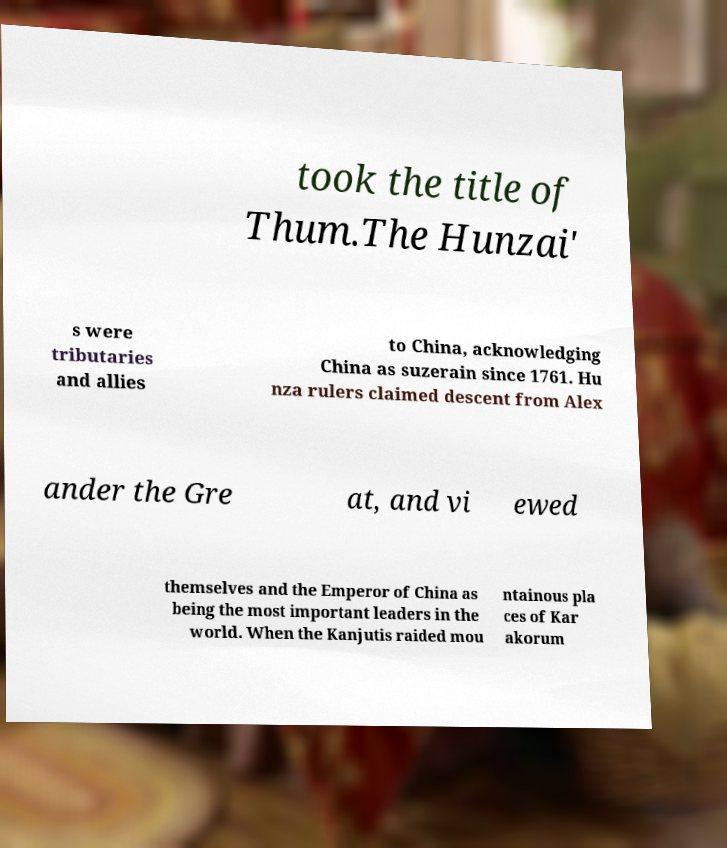Can you accurately transcribe the text from the provided image for me? took the title of Thum.The Hunzai' s were tributaries and allies to China, acknowledging China as suzerain since 1761. Hu nza rulers claimed descent from Alex ander the Gre at, and vi ewed themselves and the Emperor of China as being the most important leaders in the world. When the Kanjutis raided mou ntainous pla ces of Kar akorum 